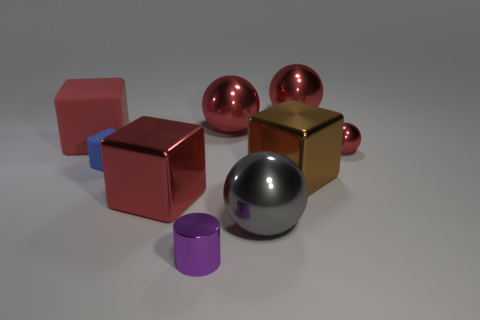What material is the brown object that is the same size as the red metal block?
Make the answer very short. Metal. There is a small metal object that is to the right of the large gray thing; is its color the same as the large sphere in front of the red matte block?
Offer a terse response. No. Is there a red object that has the same shape as the large brown metallic thing?
Provide a succinct answer. Yes. The blue thing that is the same size as the cylinder is what shape?
Your answer should be very brief. Cube. What number of metallic balls have the same color as the tiny rubber thing?
Keep it short and to the point. 0. How big is the object that is on the left side of the small blue object?
Your answer should be compact. Large. How many blue matte objects are the same size as the purple cylinder?
Give a very brief answer. 1. There is a tiny cylinder that is the same material as the tiny red sphere; what is its color?
Your response must be concise. Purple. Are there fewer rubber blocks left of the brown cube than blue shiny spheres?
Provide a succinct answer. No. The gray object that is the same material as the small sphere is what shape?
Keep it short and to the point. Sphere. 